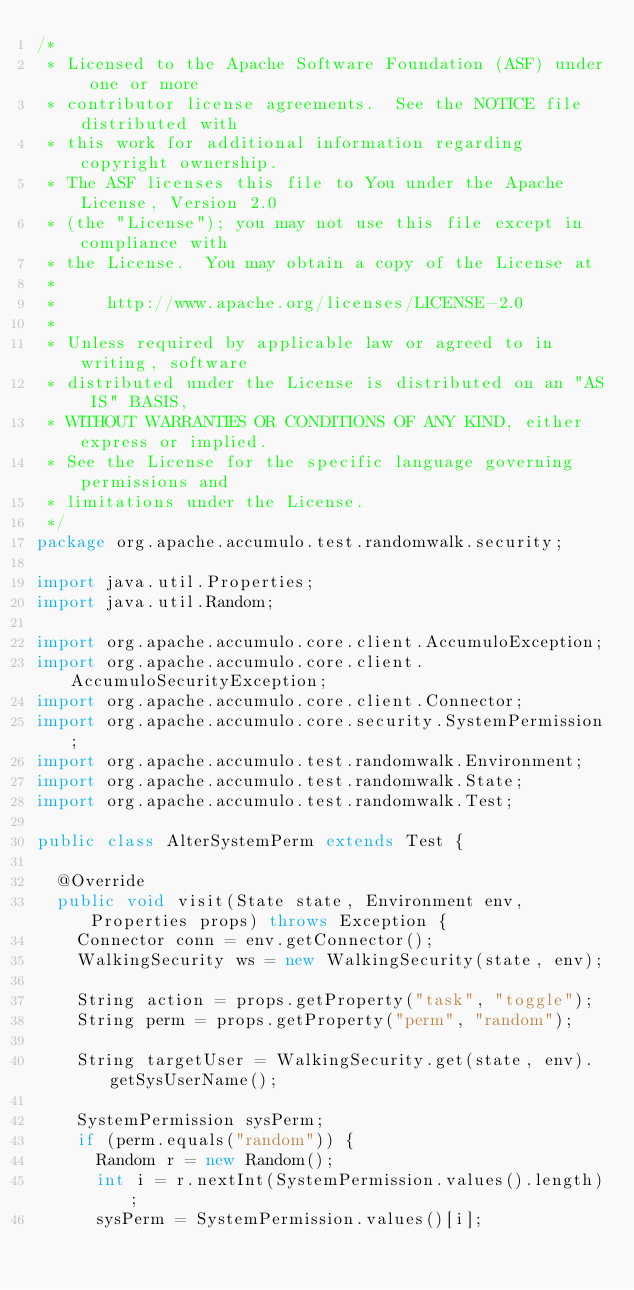<code> <loc_0><loc_0><loc_500><loc_500><_Java_>/*
 * Licensed to the Apache Software Foundation (ASF) under one or more
 * contributor license agreements.  See the NOTICE file distributed with
 * this work for additional information regarding copyright ownership.
 * The ASF licenses this file to You under the Apache License, Version 2.0
 * (the "License"); you may not use this file except in compliance with
 * the License.  You may obtain a copy of the License at
 *
 *     http://www.apache.org/licenses/LICENSE-2.0
 *
 * Unless required by applicable law or agreed to in writing, software
 * distributed under the License is distributed on an "AS IS" BASIS,
 * WITHOUT WARRANTIES OR CONDITIONS OF ANY KIND, either express or implied.
 * See the License for the specific language governing permissions and
 * limitations under the License.
 */
package org.apache.accumulo.test.randomwalk.security;

import java.util.Properties;
import java.util.Random;

import org.apache.accumulo.core.client.AccumuloException;
import org.apache.accumulo.core.client.AccumuloSecurityException;
import org.apache.accumulo.core.client.Connector;
import org.apache.accumulo.core.security.SystemPermission;
import org.apache.accumulo.test.randomwalk.Environment;
import org.apache.accumulo.test.randomwalk.State;
import org.apache.accumulo.test.randomwalk.Test;

public class AlterSystemPerm extends Test {

  @Override
  public void visit(State state, Environment env, Properties props) throws Exception {
    Connector conn = env.getConnector();
    WalkingSecurity ws = new WalkingSecurity(state, env);

    String action = props.getProperty("task", "toggle");
    String perm = props.getProperty("perm", "random");

    String targetUser = WalkingSecurity.get(state, env).getSysUserName();

    SystemPermission sysPerm;
    if (perm.equals("random")) {
      Random r = new Random();
      int i = r.nextInt(SystemPermission.values().length);
      sysPerm = SystemPermission.values()[i];</code> 